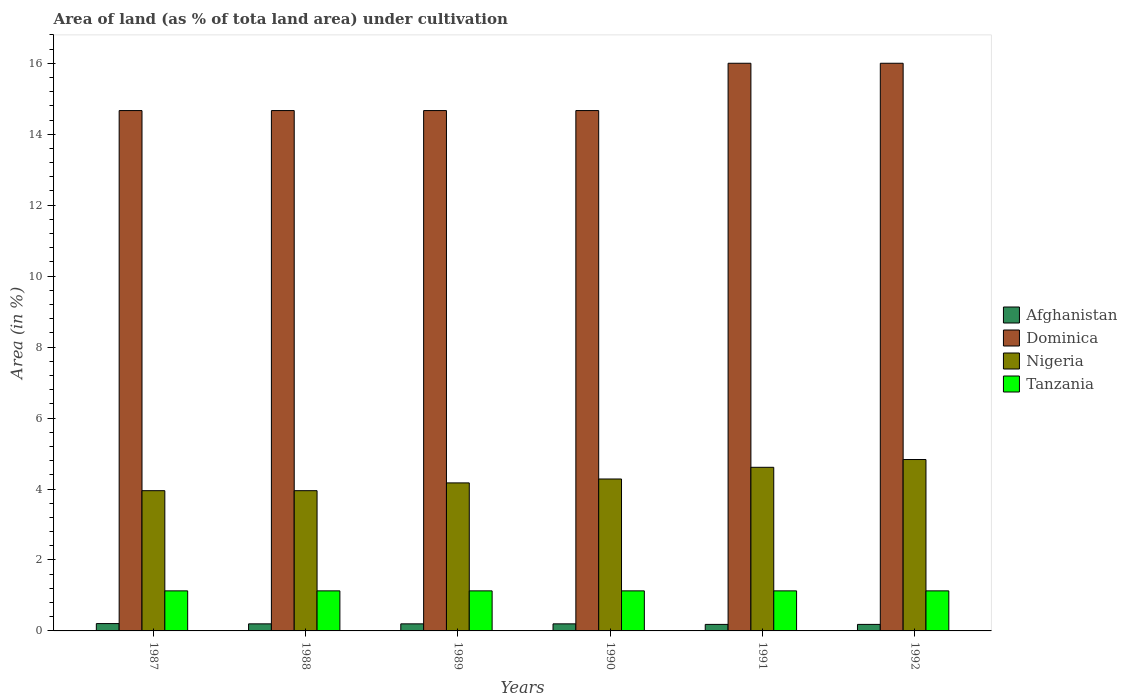How many groups of bars are there?
Provide a short and direct response. 6. Are the number of bars on each tick of the X-axis equal?
Provide a short and direct response. Yes. In how many cases, is the number of bars for a given year not equal to the number of legend labels?
Your answer should be very brief. 0. What is the percentage of land under cultivation in Afghanistan in 1992?
Offer a terse response. 0.18. Across all years, what is the maximum percentage of land under cultivation in Dominica?
Keep it short and to the point. 16. Across all years, what is the minimum percentage of land under cultivation in Dominica?
Ensure brevity in your answer.  14.67. What is the total percentage of land under cultivation in Nigeria in the graph?
Give a very brief answer. 25.8. What is the difference between the percentage of land under cultivation in Dominica in 1987 and the percentage of land under cultivation in Tanzania in 1991?
Your response must be concise. 13.54. What is the average percentage of land under cultivation in Nigeria per year?
Your answer should be compact. 4.3. In the year 1989, what is the difference between the percentage of land under cultivation in Afghanistan and percentage of land under cultivation in Nigeria?
Offer a terse response. -3.97. What is the ratio of the percentage of land under cultivation in Afghanistan in 1987 to that in 1989?
Offer a terse response. 1.04. Is the difference between the percentage of land under cultivation in Afghanistan in 1989 and 1990 greater than the difference between the percentage of land under cultivation in Nigeria in 1989 and 1990?
Make the answer very short. Yes. What is the difference between the highest and the second highest percentage of land under cultivation in Dominica?
Your answer should be compact. 0. What is the difference between the highest and the lowest percentage of land under cultivation in Dominica?
Make the answer very short. 1.33. Is it the case that in every year, the sum of the percentage of land under cultivation in Tanzania and percentage of land under cultivation in Dominica is greater than the sum of percentage of land under cultivation in Afghanistan and percentage of land under cultivation in Nigeria?
Ensure brevity in your answer.  Yes. What does the 4th bar from the left in 1988 represents?
Make the answer very short. Tanzania. What does the 1st bar from the right in 1992 represents?
Make the answer very short. Tanzania. Is it the case that in every year, the sum of the percentage of land under cultivation in Tanzania and percentage of land under cultivation in Dominica is greater than the percentage of land under cultivation in Afghanistan?
Provide a succinct answer. Yes. How many bars are there?
Ensure brevity in your answer.  24. Are all the bars in the graph horizontal?
Make the answer very short. No. What is the difference between two consecutive major ticks on the Y-axis?
Give a very brief answer. 2. Does the graph contain grids?
Your answer should be compact. No. Where does the legend appear in the graph?
Provide a short and direct response. Center right. How are the legend labels stacked?
Keep it short and to the point. Vertical. What is the title of the graph?
Offer a very short reply. Area of land (as % of tota land area) under cultivation. Does "Panama" appear as one of the legend labels in the graph?
Provide a short and direct response. No. What is the label or title of the Y-axis?
Offer a terse response. Area (in %). What is the Area (in %) of Afghanistan in 1987?
Offer a terse response. 0.21. What is the Area (in %) of Dominica in 1987?
Ensure brevity in your answer.  14.67. What is the Area (in %) in Nigeria in 1987?
Offer a very short reply. 3.95. What is the Area (in %) of Tanzania in 1987?
Your answer should be compact. 1.13. What is the Area (in %) in Afghanistan in 1988?
Offer a very short reply. 0.2. What is the Area (in %) in Dominica in 1988?
Your answer should be very brief. 14.67. What is the Area (in %) in Nigeria in 1988?
Provide a succinct answer. 3.95. What is the Area (in %) in Tanzania in 1988?
Keep it short and to the point. 1.13. What is the Area (in %) in Afghanistan in 1989?
Provide a succinct answer. 0.2. What is the Area (in %) in Dominica in 1989?
Provide a succinct answer. 14.67. What is the Area (in %) in Nigeria in 1989?
Offer a very short reply. 4.17. What is the Area (in %) of Tanzania in 1989?
Make the answer very short. 1.13. What is the Area (in %) in Afghanistan in 1990?
Provide a short and direct response. 0.2. What is the Area (in %) in Dominica in 1990?
Your answer should be very brief. 14.67. What is the Area (in %) of Nigeria in 1990?
Ensure brevity in your answer.  4.28. What is the Area (in %) in Tanzania in 1990?
Offer a very short reply. 1.13. What is the Area (in %) in Afghanistan in 1991?
Offer a very short reply. 0.18. What is the Area (in %) in Dominica in 1991?
Keep it short and to the point. 16. What is the Area (in %) of Nigeria in 1991?
Provide a short and direct response. 4.61. What is the Area (in %) of Tanzania in 1991?
Offer a very short reply. 1.13. What is the Area (in %) in Afghanistan in 1992?
Your answer should be compact. 0.18. What is the Area (in %) of Dominica in 1992?
Your answer should be compact. 16. What is the Area (in %) of Nigeria in 1992?
Offer a terse response. 4.83. What is the Area (in %) of Tanzania in 1992?
Your response must be concise. 1.13. Across all years, what is the maximum Area (in %) of Afghanistan?
Provide a short and direct response. 0.21. Across all years, what is the maximum Area (in %) in Nigeria?
Offer a very short reply. 4.83. Across all years, what is the maximum Area (in %) of Tanzania?
Provide a succinct answer. 1.13. Across all years, what is the minimum Area (in %) in Afghanistan?
Keep it short and to the point. 0.18. Across all years, what is the minimum Area (in %) in Dominica?
Give a very brief answer. 14.67. Across all years, what is the minimum Area (in %) in Nigeria?
Provide a short and direct response. 3.95. Across all years, what is the minimum Area (in %) in Tanzania?
Provide a short and direct response. 1.13. What is the total Area (in %) of Afghanistan in the graph?
Your response must be concise. 1.17. What is the total Area (in %) of Dominica in the graph?
Give a very brief answer. 90.67. What is the total Area (in %) of Nigeria in the graph?
Offer a terse response. 25.8. What is the total Area (in %) in Tanzania in the graph?
Ensure brevity in your answer.  6.77. What is the difference between the Area (in %) of Afghanistan in 1987 and that in 1988?
Your answer should be compact. 0.01. What is the difference between the Area (in %) in Nigeria in 1987 and that in 1988?
Make the answer very short. 0. What is the difference between the Area (in %) in Tanzania in 1987 and that in 1988?
Your answer should be very brief. 0. What is the difference between the Area (in %) of Afghanistan in 1987 and that in 1989?
Offer a terse response. 0.01. What is the difference between the Area (in %) in Nigeria in 1987 and that in 1989?
Provide a succinct answer. -0.22. What is the difference between the Area (in %) in Afghanistan in 1987 and that in 1990?
Make the answer very short. 0.01. What is the difference between the Area (in %) of Nigeria in 1987 and that in 1990?
Your response must be concise. -0.33. What is the difference between the Area (in %) of Tanzania in 1987 and that in 1990?
Offer a terse response. 0. What is the difference between the Area (in %) of Afghanistan in 1987 and that in 1991?
Provide a succinct answer. 0.02. What is the difference between the Area (in %) in Dominica in 1987 and that in 1991?
Ensure brevity in your answer.  -1.33. What is the difference between the Area (in %) of Nigeria in 1987 and that in 1991?
Your answer should be very brief. -0.66. What is the difference between the Area (in %) in Tanzania in 1987 and that in 1991?
Ensure brevity in your answer.  0. What is the difference between the Area (in %) in Afghanistan in 1987 and that in 1992?
Offer a very short reply. 0.02. What is the difference between the Area (in %) of Dominica in 1987 and that in 1992?
Your response must be concise. -1.33. What is the difference between the Area (in %) in Nigeria in 1987 and that in 1992?
Make the answer very short. -0.88. What is the difference between the Area (in %) in Tanzania in 1987 and that in 1992?
Your answer should be compact. 0. What is the difference between the Area (in %) of Dominica in 1988 and that in 1989?
Offer a very short reply. 0. What is the difference between the Area (in %) of Nigeria in 1988 and that in 1989?
Your answer should be very brief. -0.22. What is the difference between the Area (in %) of Tanzania in 1988 and that in 1989?
Provide a short and direct response. 0. What is the difference between the Area (in %) of Afghanistan in 1988 and that in 1990?
Your answer should be very brief. 0. What is the difference between the Area (in %) of Dominica in 1988 and that in 1990?
Offer a very short reply. 0. What is the difference between the Area (in %) of Nigeria in 1988 and that in 1990?
Provide a short and direct response. -0.33. What is the difference between the Area (in %) of Tanzania in 1988 and that in 1990?
Provide a succinct answer. 0. What is the difference between the Area (in %) of Afghanistan in 1988 and that in 1991?
Your response must be concise. 0.02. What is the difference between the Area (in %) in Dominica in 1988 and that in 1991?
Your answer should be very brief. -1.33. What is the difference between the Area (in %) of Nigeria in 1988 and that in 1991?
Ensure brevity in your answer.  -0.66. What is the difference between the Area (in %) in Afghanistan in 1988 and that in 1992?
Your answer should be very brief. 0.02. What is the difference between the Area (in %) in Dominica in 1988 and that in 1992?
Your answer should be very brief. -1.33. What is the difference between the Area (in %) of Nigeria in 1988 and that in 1992?
Your answer should be very brief. -0.88. What is the difference between the Area (in %) in Tanzania in 1988 and that in 1992?
Offer a terse response. 0. What is the difference between the Area (in %) in Dominica in 1989 and that in 1990?
Provide a succinct answer. 0. What is the difference between the Area (in %) of Nigeria in 1989 and that in 1990?
Give a very brief answer. -0.11. What is the difference between the Area (in %) in Afghanistan in 1989 and that in 1991?
Provide a short and direct response. 0.02. What is the difference between the Area (in %) in Dominica in 1989 and that in 1991?
Provide a short and direct response. -1.33. What is the difference between the Area (in %) in Nigeria in 1989 and that in 1991?
Give a very brief answer. -0.44. What is the difference between the Area (in %) of Tanzania in 1989 and that in 1991?
Provide a succinct answer. 0. What is the difference between the Area (in %) in Afghanistan in 1989 and that in 1992?
Offer a very short reply. 0.02. What is the difference between the Area (in %) in Dominica in 1989 and that in 1992?
Ensure brevity in your answer.  -1.33. What is the difference between the Area (in %) of Nigeria in 1989 and that in 1992?
Offer a very short reply. -0.66. What is the difference between the Area (in %) of Tanzania in 1989 and that in 1992?
Make the answer very short. 0. What is the difference between the Area (in %) in Afghanistan in 1990 and that in 1991?
Your response must be concise. 0.02. What is the difference between the Area (in %) in Dominica in 1990 and that in 1991?
Your answer should be compact. -1.33. What is the difference between the Area (in %) in Nigeria in 1990 and that in 1991?
Make the answer very short. -0.33. What is the difference between the Area (in %) of Tanzania in 1990 and that in 1991?
Keep it short and to the point. 0. What is the difference between the Area (in %) in Afghanistan in 1990 and that in 1992?
Give a very brief answer. 0.02. What is the difference between the Area (in %) of Dominica in 1990 and that in 1992?
Offer a terse response. -1.33. What is the difference between the Area (in %) in Nigeria in 1990 and that in 1992?
Offer a terse response. -0.55. What is the difference between the Area (in %) of Nigeria in 1991 and that in 1992?
Offer a terse response. -0.22. What is the difference between the Area (in %) in Tanzania in 1991 and that in 1992?
Your answer should be compact. 0. What is the difference between the Area (in %) in Afghanistan in 1987 and the Area (in %) in Dominica in 1988?
Ensure brevity in your answer.  -14.46. What is the difference between the Area (in %) of Afghanistan in 1987 and the Area (in %) of Nigeria in 1988?
Provide a succinct answer. -3.75. What is the difference between the Area (in %) of Afghanistan in 1987 and the Area (in %) of Tanzania in 1988?
Offer a very short reply. -0.92. What is the difference between the Area (in %) in Dominica in 1987 and the Area (in %) in Nigeria in 1988?
Offer a very short reply. 10.71. What is the difference between the Area (in %) in Dominica in 1987 and the Area (in %) in Tanzania in 1988?
Your answer should be compact. 13.54. What is the difference between the Area (in %) in Nigeria in 1987 and the Area (in %) in Tanzania in 1988?
Provide a short and direct response. 2.82. What is the difference between the Area (in %) of Afghanistan in 1987 and the Area (in %) of Dominica in 1989?
Provide a short and direct response. -14.46. What is the difference between the Area (in %) in Afghanistan in 1987 and the Area (in %) in Nigeria in 1989?
Offer a terse response. -3.97. What is the difference between the Area (in %) of Afghanistan in 1987 and the Area (in %) of Tanzania in 1989?
Your response must be concise. -0.92. What is the difference between the Area (in %) of Dominica in 1987 and the Area (in %) of Nigeria in 1989?
Ensure brevity in your answer.  10.49. What is the difference between the Area (in %) in Dominica in 1987 and the Area (in %) in Tanzania in 1989?
Give a very brief answer. 13.54. What is the difference between the Area (in %) of Nigeria in 1987 and the Area (in %) of Tanzania in 1989?
Provide a short and direct response. 2.82. What is the difference between the Area (in %) of Afghanistan in 1987 and the Area (in %) of Dominica in 1990?
Provide a succinct answer. -14.46. What is the difference between the Area (in %) of Afghanistan in 1987 and the Area (in %) of Nigeria in 1990?
Provide a short and direct response. -4.08. What is the difference between the Area (in %) of Afghanistan in 1987 and the Area (in %) of Tanzania in 1990?
Your response must be concise. -0.92. What is the difference between the Area (in %) of Dominica in 1987 and the Area (in %) of Nigeria in 1990?
Your response must be concise. 10.38. What is the difference between the Area (in %) of Dominica in 1987 and the Area (in %) of Tanzania in 1990?
Your answer should be very brief. 13.54. What is the difference between the Area (in %) of Nigeria in 1987 and the Area (in %) of Tanzania in 1990?
Keep it short and to the point. 2.82. What is the difference between the Area (in %) in Afghanistan in 1987 and the Area (in %) in Dominica in 1991?
Provide a short and direct response. -15.79. What is the difference between the Area (in %) in Afghanistan in 1987 and the Area (in %) in Nigeria in 1991?
Ensure brevity in your answer.  -4.4. What is the difference between the Area (in %) in Afghanistan in 1987 and the Area (in %) in Tanzania in 1991?
Your response must be concise. -0.92. What is the difference between the Area (in %) in Dominica in 1987 and the Area (in %) in Nigeria in 1991?
Ensure brevity in your answer.  10.06. What is the difference between the Area (in %) in Dominica in 1987 and the Area (in %) in Tanzania in 1991?
Offer a very short reply. 13.54. What is the difference between the Area (in %) of Nigeria in 1987 and the Area (in %) of Tanzania in 1991?
Offer a terse response. 2.82. What is the difference between the Area (in %) in Afghanistan in 1987 and the Area (in %) in Dominica in 1992?
Give a very brief answer. -15.79. What is the difference between the Area (in %) in Afghanistan in 1987 and the Area (in %) in Nigeria in 1992?
Provide a short and direct response. -4.62. What is the difference between the Area (in %) in Afghanistan in 1987 and the Area (in %) in Tanzania in 1992?
Your answer should be compact. -0.92. What is the difference between the Area (in %) in Dominica in 1987 and the Area (in %) in Nigeria in 1992?
Your response must be concise. 9.84. What is the difference between the Area (in %) of Dominica in 1987 and the Area (in %) of Tanzania in 1992?
Your answer should be compact. 13.54. What is the difference between the Area (in %) in Nigeria in 1987 and the Area (in %) in Tanzania in 1992?
Keep it short and to the point. 2.82. What is the difference between the Area (in %) in Afghanistan in 1988 and the Area (in %) in Dominica in 1989?
Make the answer very short. -14.47. What is the difference between the Area (in %) of Afghanistan in 1988 and the Area (in %) of Nigeria in 1989?
Provide a succinct answer. -3.97. What is the difference between the Area (in %) in Afghanistan in 1988 and the Area (in %) in Tanzania in 1989?
Ensure brevity in your answer.  -0.93. What is the difference between the Area (in %) in Dominica in 1988 and the Area (in %) in Nigeria in 1989?
Ensure brevity in your answer.  10.49. What is the difference between the Area (in %) in Dominica in 1988 and the Area (in %) in Tanzania in 1989?
Offer a very short reply. 13.54. What is the difference between the Area (in %) of Nigeria in 1988 and the Area (in %) of Tanzania in 1989?
Keep it short and to the point. 2.82. What is the difference between the Area (in %) of Afghanistan in 1988 and the Area (in %) of Dominica in 1990?
Make the answer very short. -14.47. What is the difference between the Area (in %) in Afghanistan in 1988 and the Area (in %) in Nigeria in 1990?
Provide a succinct answer. -4.08. What is the difference between the Area (in %) in Afghanistan in 1988 and the Area (in %) in Tanzania in 1990?
Offer a terse response. -0.93. What is the difference between the Area (in %) of Dominica in 1988 and the Area (in %) of Nigeria in 1990?
Your answer should be very brief. 10.38. What is the difference between the Area (in %) in Dominica in 1988 and the Area (in %) in Tanzania in 1990?
Ensure brevity in your answer.  13.54. What is the difference between the Area (in %) of Nigeria in 1988 and the Area (in %) of Tanzania in 1990?
Offer a very short reply. 2.82. What is the difference between the Area (in %) of Afghanistan in 1988 and the Area (in %) of Dominica in 1991?
Make the answer very short. -15.8. What is the difference between the Area (in %) of Afghanistan in 1988 and the Area (in %) of Nigeria in 1991?
Provide a short and direct response. -4.41. What is the difference between the Area (in %) in Afghanistan in 1988 and the Area (in %) in Tanzania in 1991?
Offer a terse response. -0.93. What is the difference between the Area (in %) in Dominica in 1988 and the Area (in %) in Nigeria in 1991?
Offer a very short reply. 10.06. What is the difference between the Area (in %) in Dominica in 1988 and the Area (in %) in Tanzania in 1991?
Your answer should be very brief. 13.54. What is the difference between the Area (in %) in Nigeria in 1988 and the Area (in %) in Tanzania in 1991?
Offer a very short reply. 2.82. What is the difference between the Area (in %) in Afghanistan in 1988 and the Area (in %) in Dominica in 1992?
Make the answer very short. -15.8. What is the difference between the Area (in %) in Afghanistan in 1988 and the Area (in %) in Nigeria in 1992?
Provide a short and direct response. -4.63. What is the difference between the Area (in %) of Afghanistan in 1988 and the Area (in %) of Tanzania in 1992?
Offer a terse response. -0.93. What is the difference between the Area (in %) in Dominica in 1988 and the Area (in %) in Nigeria in 1992?
Your response must be concise. 9.84. What is the difference between the Area (in %) in Dominica in 1988 and the Area (in %) in Tanzania in 1992?
Offer a terse response. 13.54. What is the difference between the Area (in %) of Nigeria in 1988 and the Area (in %) of Tanzania in 1992?
Ensure brevity in your answer.  2.82. What is the difference between the Area (in %) of Afghanistan in 1989 and the Area (in %) of Dominica in 1990?
Keep it short and to the point. -14.47. What is the difference between the Area (in %) of Afghanistan in 1989 and the Area (in %) of Nigeria in 1990?
Offer a terse response. -4.08. What is the difference between the Area (in %) in Afghanistan in 1989 and the Area (in %) in Tanzania in 1990?
Offer a terse response. -0.93. What is the difference between the Area (in %) in Dominica in 1989 and the Area (in %) in Nigeria in 1990?
Provide a succinct answer. 10.38. What is the difference between the Area (in %) of Dominica in 1989 and the Area (in %) of Tanzania in 1990?
Give a very brief answer. 13.54. What is the difference between the Area (in %) in Nigeria in 1989 and the Area (in %) in Tanzania in 1990?
Keep it short and to the point. 3.04. What is the difference between the Area (in %) of Afghanistan in 1989 and the Area (in %) of Dominica in 1991?
Ensure brevity in your answer.  -15.8. What is the difference between the Area (in %) of Afghanistan in 1989 and the Area (in %) of Nigeria in 1991?
Keep it short and to the point. -4.41. What is the difference between the Area (in %) of Afghanistan in 1989 and the Area (in %) of Tanzania in 1991?
Give a very brief answer. -0.93. What is the difference between the Area (in %) of Dominica in 1989 and the Area (in %) of Nigeria in 1991?
Offer a terse response. 10.06. What is the difference between the Area (in %) of Dominica in 1989 and the Area (in %) of Tanzania in 1991?
Give a very brief answer. 13.54. What is the difference between the Area (in %) of Nigeria in 1989 and the Area (in %) of Tanzania in 1991?
Provide a succinct answer. 3.04. What is the difference between the Area (in %) in Afghanistan in 1989 and the Area (in %) in Dominica in 1992?
Provide a succinct answer. -15.8. What is the difference between the Area (in %) in Afghanistan in 1989 and the Area (in %) in Nigeria in 1992?
Offer a terse response. -4.63. What is the difference between the Area (in %) of Afghanistan in 1989 and the Area (in %) of Tanzania in 1992?
Keep it short and to the point. -0.93. What is the difference between the Area (in %) in Dominica in 1989 and the Area (in %) in Nigeria in 1992?
Your answer should be compact. 9.84. What is the difference between the Area (in %) of Dominica in 1989 and the Area (in %) of Tanzania in 1992?
Provide a succinct answer. 13.54. What is the difference between the Area (in %) of Nigeria in 1989 and the Area (in %) of Tanzania in 1992?
Your response must be concise. 3.04. What is the difference between the Area (in %) of Afghanistan in 1990 and the Area (in %) of Dominica in 1991?
Offer a terse response. -15.8. What is the difference between the Area (in %) of Afghanistan in 1990 and the Area (in %) of Nigeria in 1991?
Offer a terse response. -4.41. What is the difference between the Area (in %) of Afghanistan in 1990 and the Area (in %) of Tanzania in 1991?
Offer a very short reply. -0.93. What is the difference between the Area (in %) of Dominica in 1990 and the Area (in %) of Nigeria in 1991?
Provide a succinct answer. 10.06. What is the difference between the Area (in %) of Dominica in 1990 and the Area (in %) of Tanzania in 1991?
Provide a short and direct response. 13.54. What is the difference between the Area (in %) in Nigeria in 1990 and the Area (in %) in Tanzania in 1991?
Offer a terse response. 3.15. What is the difference between the Area (in %) of Afghanistan in 1990 and the Area (in %) of Dominica in 1992?
Your answer should be compact. -15.8. What is the difference between the Area (in %) in Afghanistan in 1990 and the Area (in %) in Nigeria in 1992?
Give a very brief answer. -4.63. What is the difference between the Area (in %) in Afghanistan in 1990 and the Area (in %) in Tanzania in 1992?
Make the answer very short. -0.93. What is the difference between the Area (in %) of Dominica in 1990 and the Area (in %) of Nigeria in 1992?
Your answer should be very brief. 9.84. What is the difference between the Area (in %) of Dominica in 1990 and the Area (in %) of Tanzania in 1992?
Keep it short and to the point. 13.54. What is the difference between the Area (in %) of Nigeria in 1990 and the Area (in %) of Tanzania in 1992?
Your answer should be very brief. 3.15. What is the difference between the Area (in %) in Afghanistan in 1991 and the Area (in %) in Dominica in 1992?
Provide a short and direct response. -15.82. What is the difference between the Area (in %) in Afghanistan in 1991 and the Area (in %) in Nigeria in 1992?
Make the answer very short. -4.65. What is the difference between the Area (in %) in Afghanistan in 1991 and the Area (in %) in Tanzania in 1992?
Your response must be concise. -0.95. What is the difference between the Area (in %) in Dominica in 1991 and the Area (in %) in Nigeria in 1992?
Make the answer very short. 11.17. What is the difference between the Area (in %) of Dominica in 1991 and the Area (in %) of Tanzania in 1992?
Your answer should be compact. 14.87. What is the difference between the Area (in %) in Nigeria in 1991 and the Area (in %) in Tanzania in 1992?
Keep it short and to the point. 3.48. What is the average Area (in %) in Afghanistan per year?
Make the answer very short. 0.2. What is the average Area (in %) of Dominica per year?
Offer a very short reply. 15.11. What is the average Area (in %) of Nigeria per year?
Your answer should be very brief. 4.3. What is the average Area (in %) of Tanzania per year?
Provide a succinct answer. 1.13. In the year 1987, what is the difference between the Area (in %) in Afghanistan and Area (in %) in Dominica?
Offer a terse response. -14.46. In the year 1987, what is the difference between the Area (in %) in Afghanistan and Area (in %) in Nigeria?
Keep it short and to the point. -3.75. In the year 1987, what is the difference between the Area (in %) in Afghanistan and Area (in %) in Tanzania?
Your answer should be compact. -0.92. In the year 1987, what is the difference between the Area (in %) of Dominica and Area (in %) of Nigeria?
Provide a succinct answer. 10.71. In the year 1987, what is the difference between the Area (in %) of Dominica and Area (in %) of Tanzania?
Provide a short and direct response. 13.54. In the year 1987, what is the difference between the Area (in %) in Nigeria and Area (in %) in Tanzania?
Offer a very short reply. 2.82. In the year 1988, what is the difference between the Area (in %) of Afghanistan and Area (in %) of Dominica?
Provide a succinct answer. -14.47. In the year 1988, what is the difference between the Area (in %) of Afghanistan and Area (in %) of Nigeria?
Provide a succinct answer. -3.75. In the year 1988, what is the difference between the Area (in %) in Afghanistan and Area (in %) in Tanzania?
Offer a very short reply. -0.93. In the year 1988, what is the difference between the Area (in %) in Dominica and Area (in %) in Nigeria?
Ensure brevity in your answer.  10.71. In the year 1988, what is the difference between the Area (in %) in Dominica and Area (in %) in Tanzania?
Provide a short and direct response. 13.54. In the year 1988, what is the difference between the Area (in %) of Nigeria and Area (in %) of Tanzania?
Offer a very short reply. 2.82. In the year 1989, what is the difference between the Area (in %) in Afghanistan and Area (in %) in Dominica?
Provide a succinct answer. -14.47. In the year 1989, what is the difference between the Area (in %) of Afghanistan and Area (in %) of Nigeria?
Ensure brevity in your answer.  -3.97. In the year 1989, what is the difference between the Area (in %) in Afghanistan and Area (in %) in Tanzania?
Your answer should be very brief. -0.93. In the year 1989, what is the difference between the Area (in %) in Dominica and Area (in %) in Nigeria?
Make the answer very short. 10.49. In the year 1989, what is the difference between the Area (in %) in Dominica and Area (in %) in Tanzania?
Provide a short and direct response. 13.54. In the year 1989, what is the difference between the Area (in %) of Nigeria and Area (in %) of Tanzania?
Offer a terse response. 3.04. In the year 1990, what is the difference between the Area (in %) of Afghanistan and Area (in %) of Dominica?
Offer a very short reply. -14.47. In the year 1990, what is the difference between the Area (in %) in Afghanistan and Area (in %) in Nigeria?
Give a very brief answer. -4.08. In the year 1990, what is the difference between the Area (in %) in Afghanistan and Area (in %) in Tanzania?
Provide a short and direct response. -0.93. In the year 1990, what is the difference between the Area (in %) in Dominica and Area (in %) in Nigeria?
Your answer should be compact. 10.38. In the year 1990, what is the difference between the Area (in %) in Dominica and Area (in %) in Tanzania?
Your answer should be very brief. 13.54. In the year 1990, what is the difference between the Area (in %) in Nigeria and Area (in %) in Tanzania?
Your answer should be very brief. 3.15. In the year 1991, what is the difference between the Area (in %) of Afghanistan and Area (in %) of Dominica?
Your response must be concise. -15.82. In the year 1991, what is the difference between the Area (in %) of Afghanistan and Area (in %) of Nigeria?
Offer a terse response. -4.43. In the year 1991, what is the difference between the Area (in %) in Afghanistan and Area (in %) in Tanzania?
Keep it short and to the point. -0.95. In the year 1991, what is the difference between the Area (in %) in Dominica and Area (in %) in Nigeria?
Offer a terse response. 11.39. In the year 1991, what is the difference between the Area (in %) in Dominica and Area (in %) in Tanzania?
Ensure brevity in your answer.  14.87. In the year 1991, what is the difference between the Area (in %) of Nigeria and Area (in %) of Tanzania?
Your answer should be very brief. 3.48. In the year 1992, what is the difference between the Area (in %) in Afghanistan and Area (in %) in Dominica?
Give a very brief answer. -15.82. In the year 1992, what is the difference between the Area (in %) of Afghanistan and Area (in %) of Nigeria?
Your answer should be compact. -4.65. In the year 1992, what is the difference between the Area (in %) in Afghanistan and Area (in %) in Tanzania?
Make the answer very short. -0.95. In the year 1992, what is the difference between the Area (in %) in Dominica and Area (in %) in Nigeria?
Make the answer very short. 11.17. In the year 1992, what is the difference between the Area (in %) of Dominica and Area (in %) of Tanzania?
Your answer should be very brief. 14.87. In the year 1992, what is the difference between the Area (in %) in Nigeria and Area (in %) in Tanzania?
Provide a succinct answer. 3.7. What is the ratio of the Area (in %) in Nigeria in 1987 to that in 1988?
Ensure brevity in your answer.  1. What is the ratio of the Area (in %) of Tanzania in 1987 to that in 1988?
Offer a very short reply. 1. What is the ratio of the Area (in %) of Afghanistan in 1987 to that in 1989?
Keep it short and to the point. 1.04. What is the ratio of the Area (in %) in Tanzania in 1987 to that in 1989?
Offer a very short reply. 1. What is the ratio of the Area (in %) of Dominica in 1987 to that in 1990?
Keep it short and to the point. 1. What is the ratio of the Area (in %) of Nigeria in 1987 to that in 1990?
Your response must be concise. 0.92. What is the ratio of the Area (in %) of Tanzania in 1987 to that in 1990?
Offer a very short reply. 1. What is the ratio of the Area (in %) in Dominica in 1987 to that in 1991?
Offer a terse response. 0.92. What is the ratio of the Area (in %) of Nigeria in 1987 to that in 1991?
Offer a terse response. 0.86. What is the ratio of the Area (in %) of Dominica in 1987 to that in 1992?
Keep it short and to the point. 0.92. What is the ratio of the Area (in %) in Nigeria in 1987 to that in 1992?
Give a very brief answer. 0.82. What is the ratio of the Area (in %) in Tanzania in 1987 to that in 1992?
Your response must be concise. 1. What is the ratio of the Area (in %) of Afghanistan in 1988 to that in 1989?
Your answer should be very brief. 1. What is the ratio of the Area (in %) in Dominica in 1988 to that in 1989?
Your answer should be compact. 1. What is the ratio of the Area (in %) in Afghanistan in 1988 to that in 1990?
Provide a succinct answer. 1. What is the ratio of the Area (in %) in Dominica in 1988 to that in 1990?
Provide a succinct answer. 1. What is the ratio of the Area (in %) of Tanzania in 1988 to that in 1990?
Your response must be concise. 1. What is the ratio of the Area (in %) of Afghanistan in 1988 to that in 1991?
Offer a terse response. 1.08. What is the ratio of the Area (in %) of Dominica in 1988 to that in 1991?
Ensure brevity in your answer.  0.92. What is the ratio of the Area (in %) in Nigeria in 1988 to that in 1991?
Ensure brevity in your answer.  0.86. What is the ratio of the Area (in %) of Tanzania in 1988 to that in 1991?
Keep it short and to the point. 1. What is the ratio of the Area (in %) of Dominica in 1988 to that in 1992?
Ensure brevity in your answer.  0.92. What is the ratio of the Area (in %) in Nigeria in 1988 to that in 1992?
Ensure brevity in your answer.  0.82. What is the ratio of the Area (in %) of Nigeria in 1989 to that in 1990?
Provide a succinct answer. 0.97. What is the ratio of the Area (in %) of Afghanistan in 1989 to that in 1991?
Provide a succinct answer. 1.08. What is the ratio of the Area (in %) in Nigeria in 1989 to that in 1991?
Provide a succinct answer. 0.9. What is the ratio of the Area (in %) of Tanzania in 1989 to that in 1991?
Ensure brevity in your answer.  1. What is the ratio of the Area (in %) in Afghanistan in 1989 to that in 1992?
Keep it short and to the point. 1.08. What is the ratio of the Area (in %) in Dominica in 1989 to that in 1992?
Ensure brevity in your answer.  0.92. What is the ratio of the Area (in %) in Nigeria in 1989 to that in 1992?
Offer a very short reply. 0.86. What is the ratio of the Area (in %) of Dominica in 1990 to that in 1991?
Your response must be concise. 0.92. What is the ratio of the Area (in %) of Afghanistan in 1990 to that in 1992?
Your answer should be very brief. 1.08. What is the ratio of the Area (in %) in Dominica in 1990 to that in 1992?
Your answer should be compact. 0.92. What is the ratio of the Area (in %) in Nigeria in 1990 to that in 1992?
Make the answer very short. 0.89. What is the ratio of the Area (in %) of Dominica in 1991 to that in 1992?
Provide a succinct answer. 1. What is the ratio of the Area (in %) of Nigeria in 1991 to that in 1992?
Give a very brief answer. 0.95. What is the ratio of the Area (in %) in Tanzania in 1991 to that in 1992?
Provide a short and direct response. 1. What is the difference between the highest and the second highest Area (in %) in Afghanistan?
Offer a very short reply. 0.01. What is the difference between the highest and the second highest Area (in %) of Dominica?
Keep it short and to the point. 0. What is the difference between the highest and the second highest Area (in %) in Nigeria?
Provide a succinct answer. 0.22. What is the difference between the highest and the lowest Area (in %) of Afghanistan?
Your answer should be compact. 0.02. What is the difference between the highest and the lowest Area (in %) in Dominica?
Provide a short and direct response. 1.33. What is the difference between the highest and the lowest Area (in %) in Nigeria?
Ensure brevity in your answer.  0.88. What is the difference between the highest and the lowest Area (in %) of Tanzania?
Your answer should be very brief. 0. 